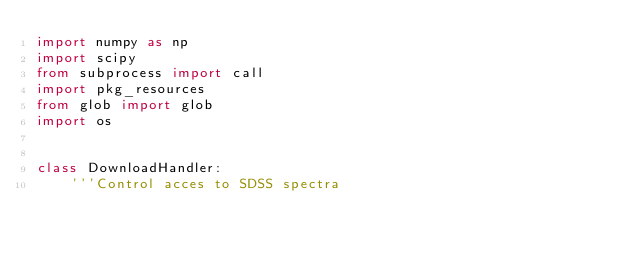<code> <loc_0><loc_0><loc_500><loc_500><_Python_>import numpy as np
import scipy
from subprocess import call
import pkg_resources
from glob import glob
import os


class DownloadHandler:
    '''Control acces to SDSS spectra
</code> 